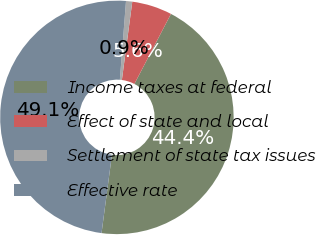Convert chart. <chart><loc_0><loc_0><loc_500><loc_500><pie_chart><fcel>Income taxes at federal<fcel>Effect of state and local<fcel>Settlement of state tax issues<fcel>Effective rate<nl><fcel>44.44%<fcel>5.56%<fcel>0.86%<fcel>49.14%<nl></chart> 